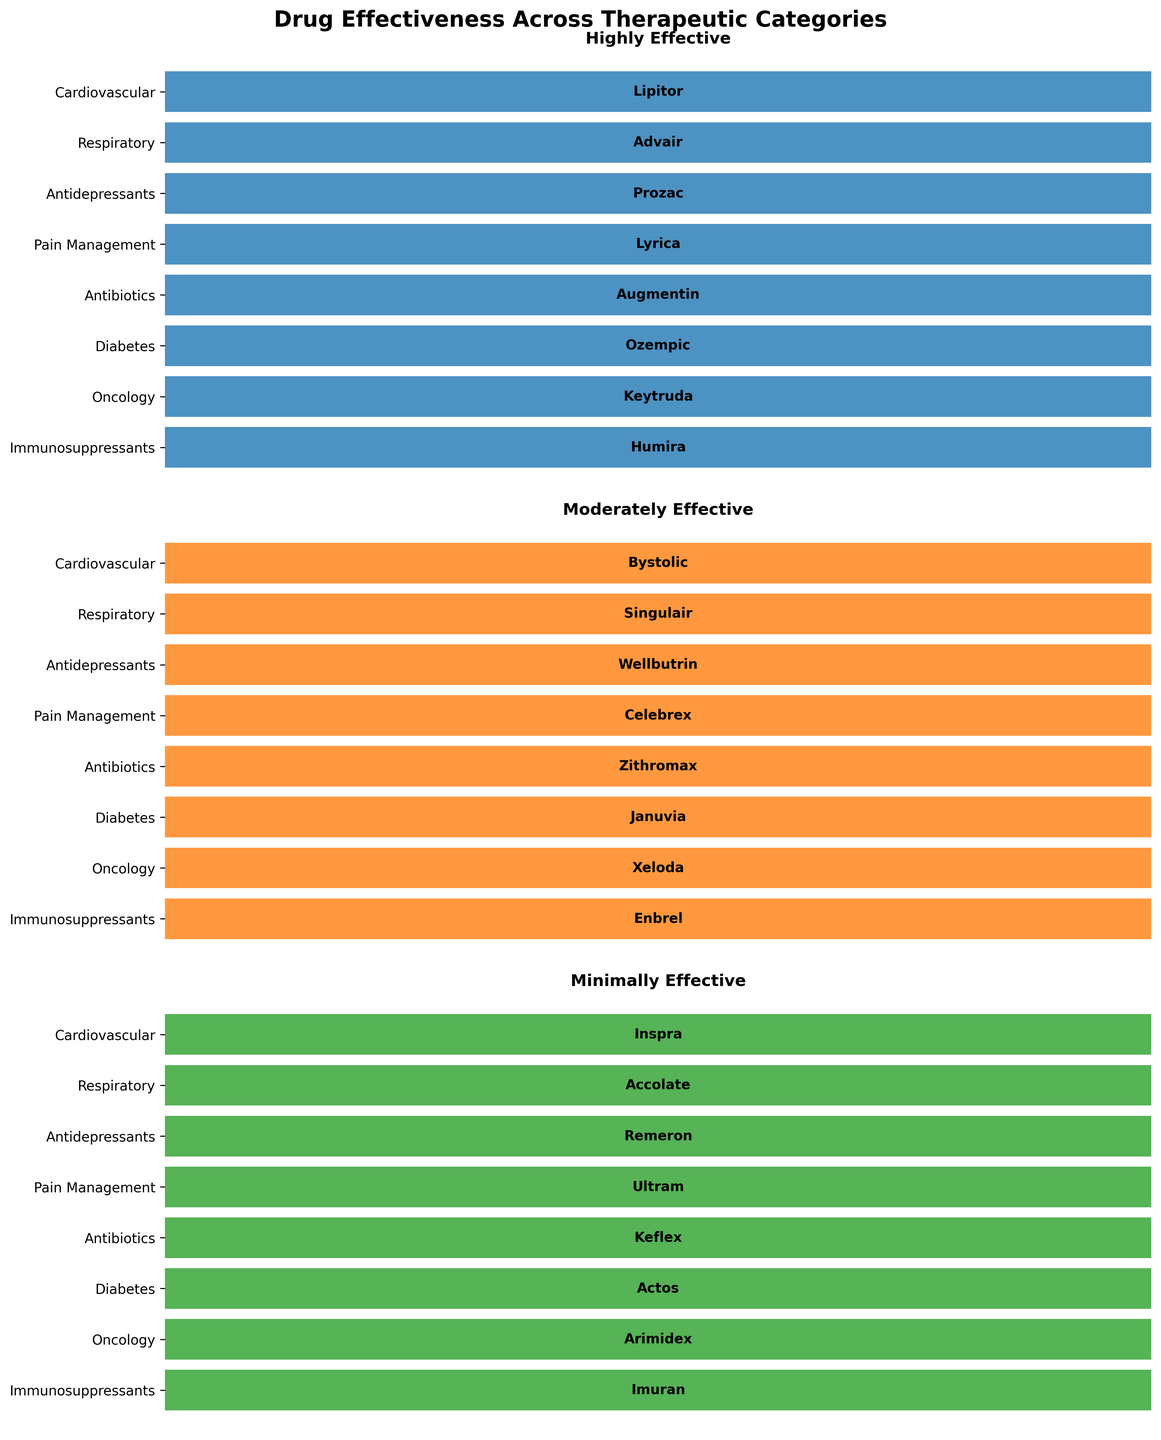What's the title of the figure? The title is usually placed at the top of the figure for easy identification. Reading it directly from the figure confirms the specific topic under analysis.
Answer: Drug Effectiveness Across Therapeutic Categories How many therapeutic categories are depicted in the figure? The therapeutic categories are listed on the vertical axis of the figure. By counting the labels, we can determine the total number of categories.
Answer: 8 Which drug is considered highly effective for Respiratory conditions? To find this, look at the second subplot titled "Highly Effective" and locate the drug corresponding to the "Respiratory" category.
Answer: Advair Which therapeutic category features the drugs Bystolic, Singulair, and Wellbutrin? Examine each subplot (Highly Effective, Moderately Effective, Minimally Effective) to find the therapeutic categories where Bystolic, Singulair, and Wellbutrin appear and see which category includes all three.
Answer: They appear in different subplots Which drug is minimally effective for Oncology? Check the last subplot titled "Minimally Effective" and find the drug listed for the Oncology category.
Answer: Arimidex Compare the highly effective drugs for Cardiovascular and Immunosuppressants categories. Which one has the longer name? Identify the drugs listed as highly effective in the "Cardiovascular" and "Immunosuppressants" categories and compare their name lengths.
Answer: Immunosuppressants (Humira) How many drugs are considered highly effective across all categories? Count the total number of drugs listed in the "Highly Effective" subplot. Each bar represents a drug for a different category.
Answer: 8 Which category has Celebrex listed, and what is its effectiveness classification? Look through the subplots and identify the category associated with Celebrex, along with noting which subplot it appears in for its effectiveness level.
Answer: Pain Management; Moderately Effective 